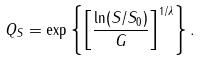<formula> <loc_0><loc_0><loc_500><loc_500>Q _ { S } = \exp \left \{ \left [ \frac { \ln ( S / S _ { 0 } ) } { G } \right ] ^ { 1 / \lambda } \right \} .</formula> 